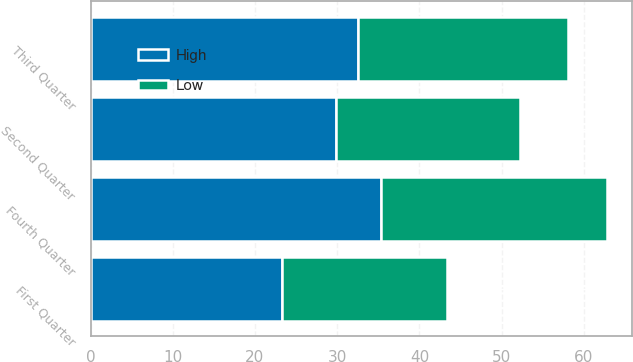Convert chart. <chart><loc_0><loc_0><loc_500><loc_500><stacked_bar_chart><ecel><fcel>Fourth Quarter<fcel>Third Quarter<fcel>Second Quarter<fcel>First Quarter<nl><fcel>High<fcel>35.28<fcel>32.57<fcel>29.85<fcel>23.34<nl><fcel>Low<fcel>27.48<fcel>25.45<fcel>22.44<fcel>19.97<nl></chart> 